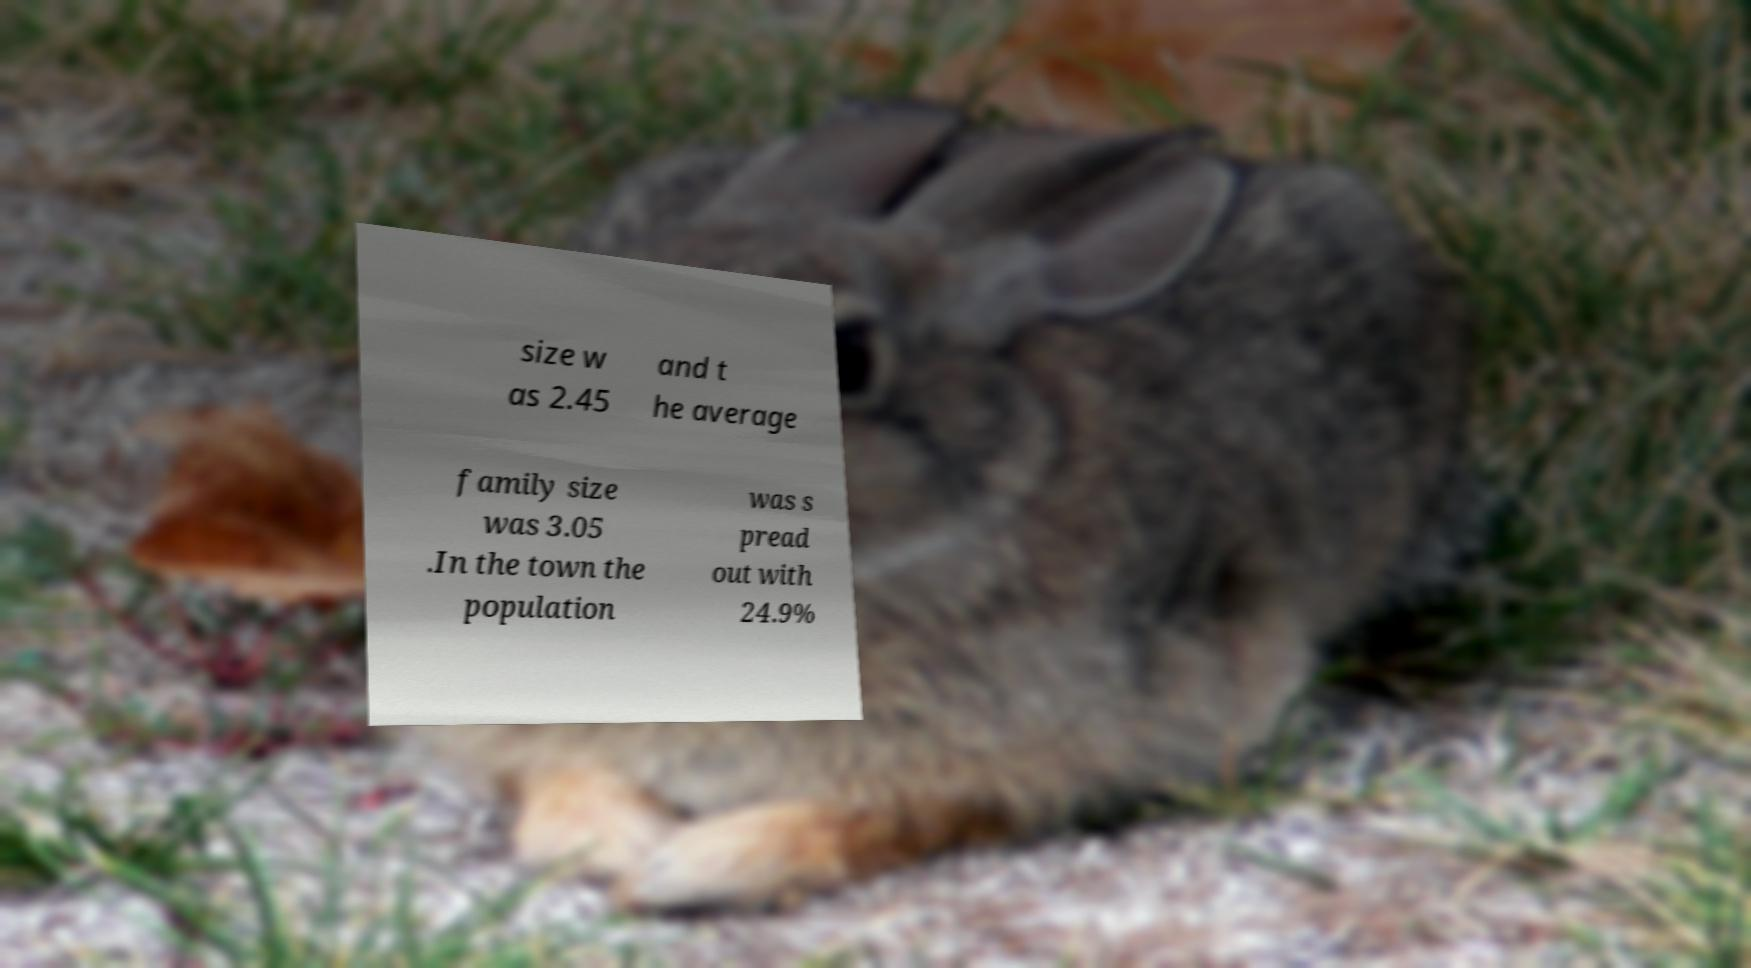Can you read and provide the text displayed in the image?This photo seems to have some interesting text. Can you extract and type it out for me? size w as 2.45 and t he average family size was 3.05 .In the town the population was s pread out with 24.9% 